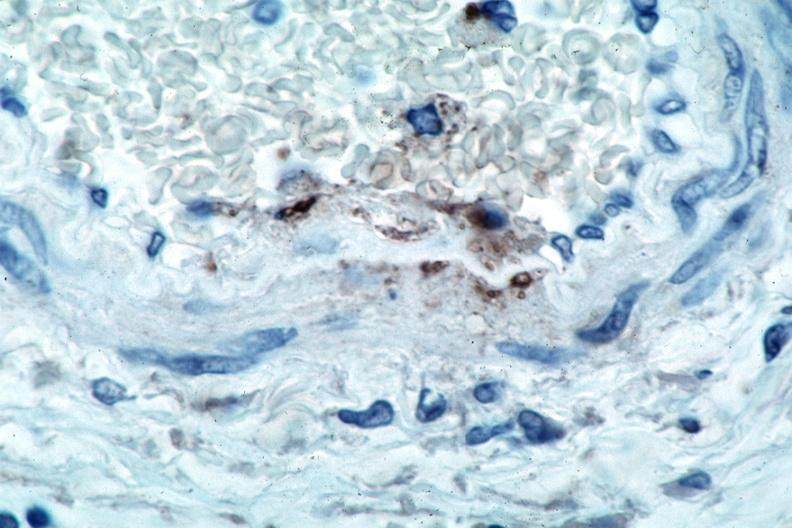s vasculature present?
Answer the question using a single word or phrase. Yes 